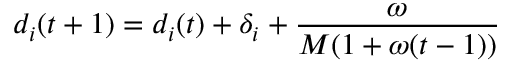Convert formula to latex. <formula><loc_0><loc_0><loc_500><loc_500>d _ { i } ( t + 1 ) = d _ { i } ( t ) + \delta _ { i } + \frac { \omega } { M ( 1 + \omega ( t - 1 ) ) }</formula> 